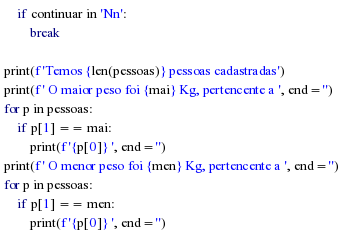Convert code to text. <code><loc_0><loc_0><loc_500><loc_500><_Python_>    if continuar in 'Nn':
        break

print(f'Temos {len(pessoas)} pessoas cadastradas')
print(f' O maior peso foi {mai} Kg, pertencente a ', end='')
for p in pessoas:
    if p[1] == mai:
        print(f'{p[0]} ', end='')
print(f' O menor peso foi {men} Kg, pertencente a ', end='')
for p in pessoas:
    if p[1] == men:
        print(f'{p[0]} ', end='')</code> 